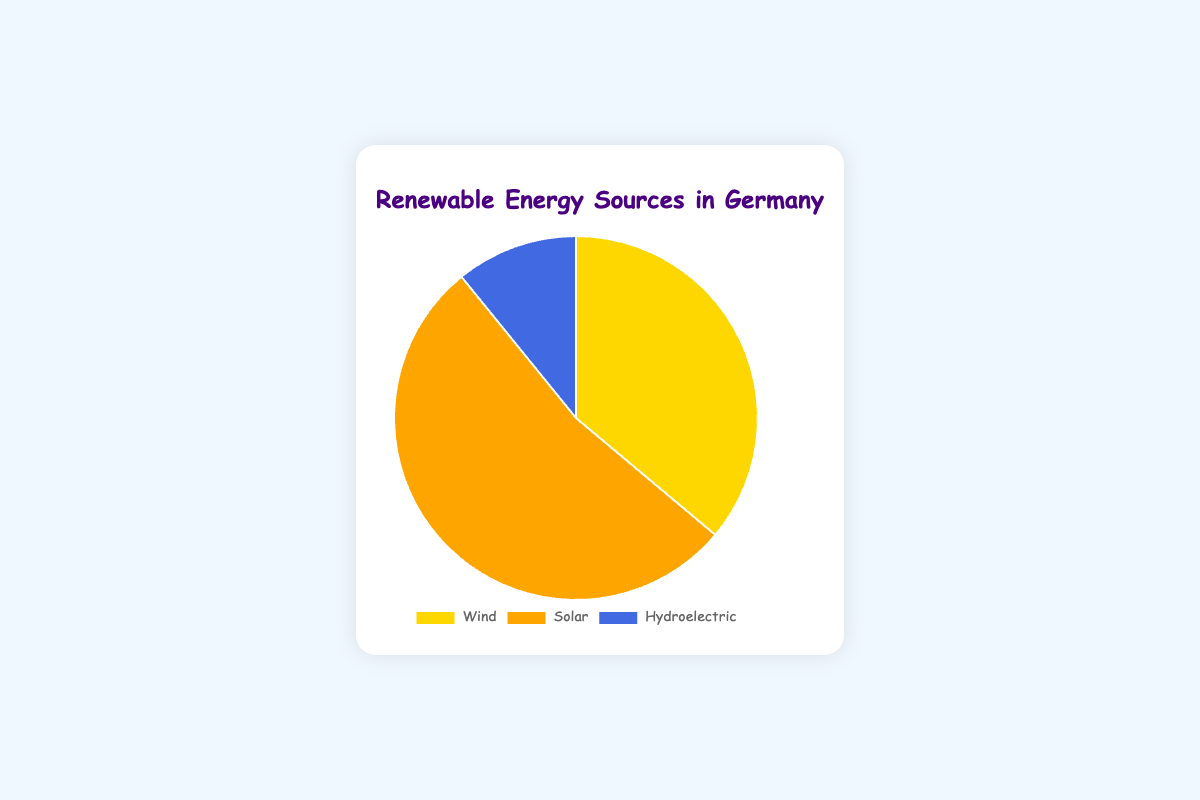Which renewable energy source contributes the most to Germany's energy mix? By observing the pie chart, we can see that the slice representing "Solar" is the largest. This indicates that Solar has the highest percentage among the renewable energy sources.
Answer: Solar What is the combined percentage of Wind and Hydroelectric energy sources? The chart shows that Wind contributes 27.3% and Hydroelectric contributes 8.2%. Adding these two percentages together gives us 27.3% + 8.2% = 35.5%.
Answer: 35.5% How much more does Solar energy contribute compared to Hydroelectric energy? Solar contributes 40.1% and Hydroelectric contributes 8.2%. The difference between these two values is 40.1% - 8.2% = 31.9%.
Answer: 31.9% Which color represents Wind energy in the chart? The pie chart uses different colors for each renewable energy source. Wind is represented by the color gold.
Answer: Gold Is the percentage of Solar energy greater than the combined percentage of Wind and Hydroelectric energy? Solar energy is 40.1%. The combined percentage of Wind and Hydroelectric is 27.3% + 8.2% = 35.5%. Since 40.1% is greater than 35.5%, Solar energy's percentage is indeed greater.
Answer: Yes 